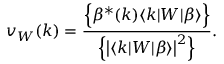Convert formula to latex. <formula><loc_0><loc_0><loc_500><loc_500>v _ { W } ( k ) = \frac { \left \{ \beta ^ { * } ( k ) \langle k | W | \beta \rangle \right \} } { \left \{ \left | \langle k | W | \beta \rangle \right | ^ { 2 } \right \} } .</formula> 